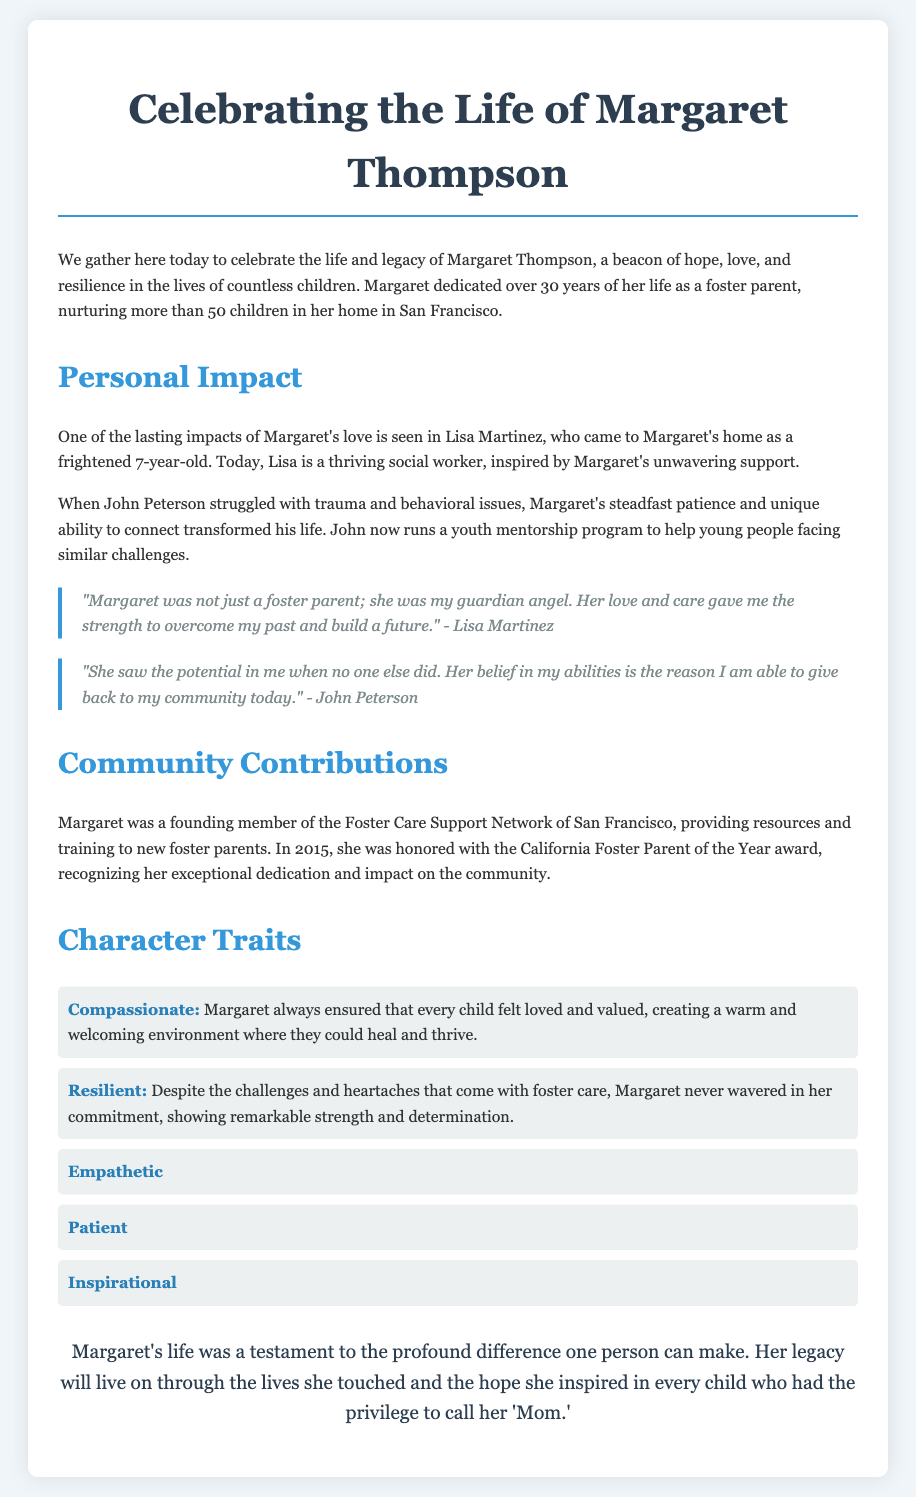What was Margaret Thompson's profession? The document states that Margaret dedicated over 30 years of her life as a foster parent.
Answer: Foster parent How many children did Margaret care for? The eulogy mentions that Margaret nurtured more than 50 children throughout her foster parenting career.
Answer: More than 50 What award did Margaret receive in 2015? The document indicates that she was honored with the California Foster Parent of the Year award in 2015 for her dedication.
Answer: California Foster Parent of the Year Who is Lisa Martinez? Lisa Martinez is mentioned as a child who came to Margaret's home and later became a thriving social worker, inspired by Margaret.
Answer: A thriving social worker What character trait describes Margaret's ability to support children through difficulties? The eulogy highlights that Margaret was resilient, showing strength and determination despite challenges.
Answer: Resilient What did John Peterson say about Margaret's belief in him? John Peterson expressed that Margaret's belief in his abilities is why he can give back to the community today.
Answer: Her belief in my abilities What organization did Margaret help establish? The document states that Margaret was a founding member of the Foster Care Support Network of San Francisco.
Answer: Foster Care Support Network of San Francisco How long did Margaret dedicate her life to foster care? According to the document, Margaret dedicated over 30 years of her life as a foster parent.
Answer: Over 30 years 